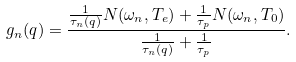Convert formula to latex. <formula><loc_0><loc_0><loc_500><loc_500>g _ { n } ( q ) = \frac { \frac { 1 } { \tau _ { n } ( q ) } N ( \omega _ { n } , T _ { e } ) + \frac { 1 } { \tau _ { p } } N ( \omega _ { n } , T _ { 0 } ) } { \frac { 1 } { \tau _ { n } ( q ) } + \frac { 1 } { \tau _ { p } } } .</formula> 